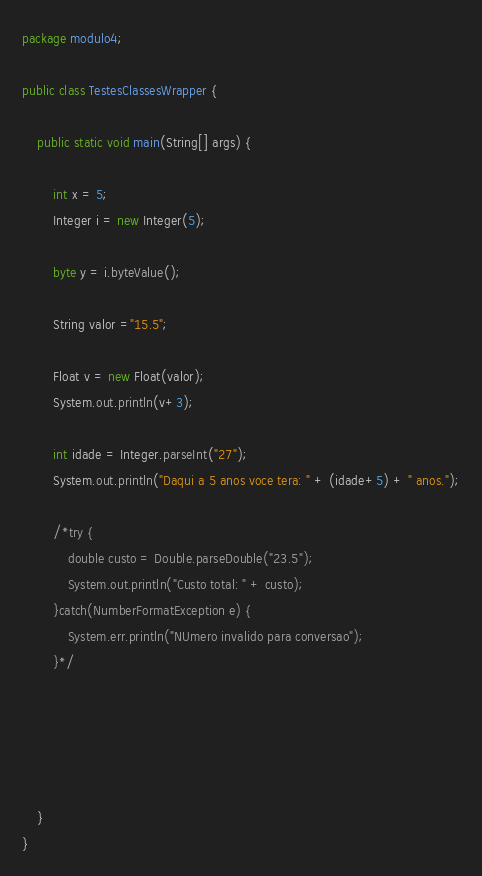Convert code to text. <code><loc_0><loc_0><loc_500><loc_500><_Java_>package modulo4;

public class TestesClassesWrapper {
	
	public static void main(String[] args) {
		
		int x = 5;
		Integer i = new Integer(5);
		
		byte y = i.byteValue();
		
		String valor ="15.5";
		
		Float v = new Float(valor);
		System.out.println(v+3);
		
		int idade = Integer.parseInt("27");
		System.out.println("Daqui a 5 anos voce tera: " + (idade+5) + " anos.");
		
		/*try {
			double custo = Double.parseDouble("23.5");
			System.out.println("Custo total: " + custo);
		}catch(NumberFormatException e) {
			System.err.println("NUmero invalido para conversao");
		}*/
		
		
		
		
		
	}
}
</code> 